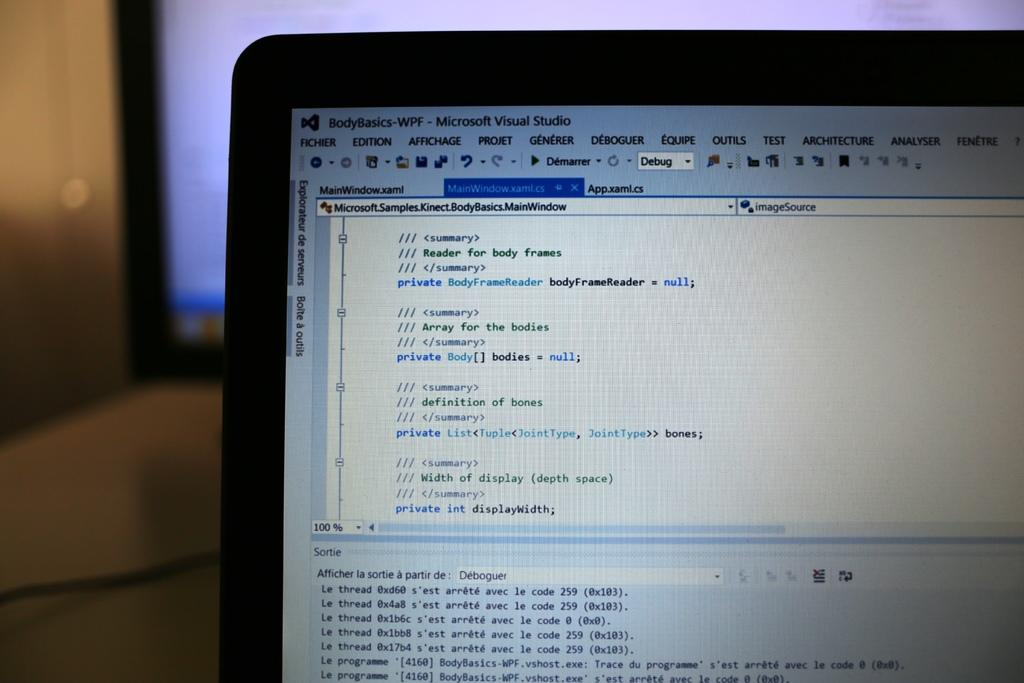<image>
Describe the image concisely. a computer screen that is open to a page that says bodybasics on it 